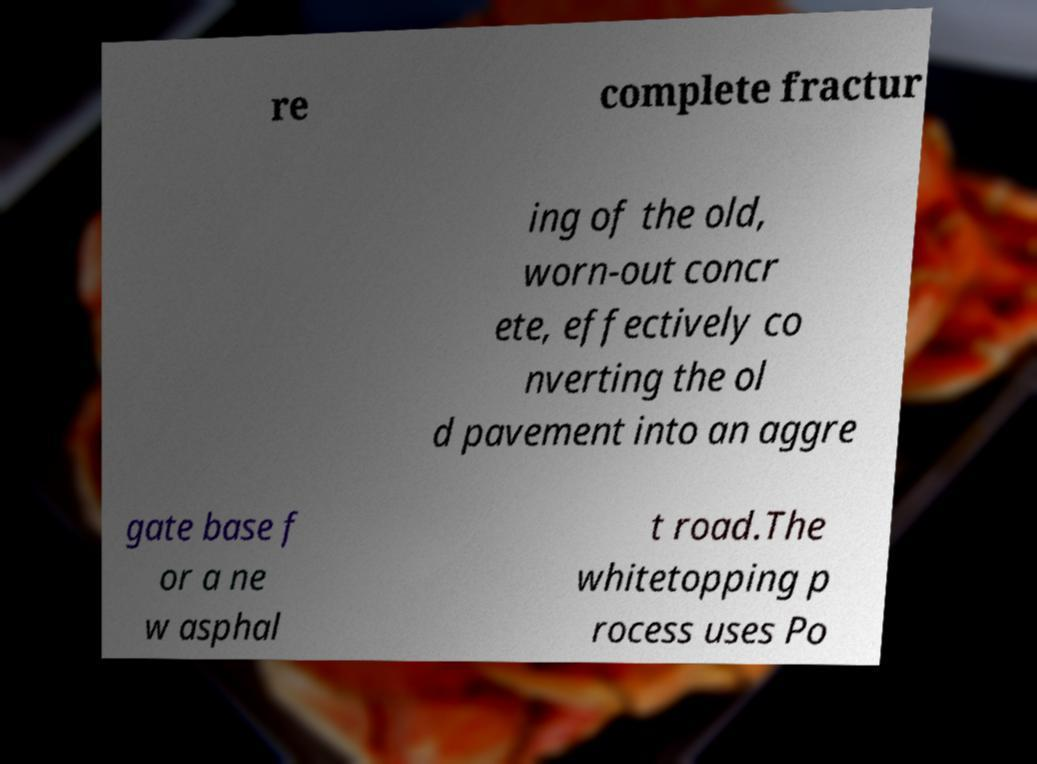Please identify and transcribe the text found in this image. re complete fractur ing of the old, worn-out concr ete, effectively co nverting the ol d pavement into an aggre gate base f or a ne w asphal t road.The whitetopping p rocess uses Po 